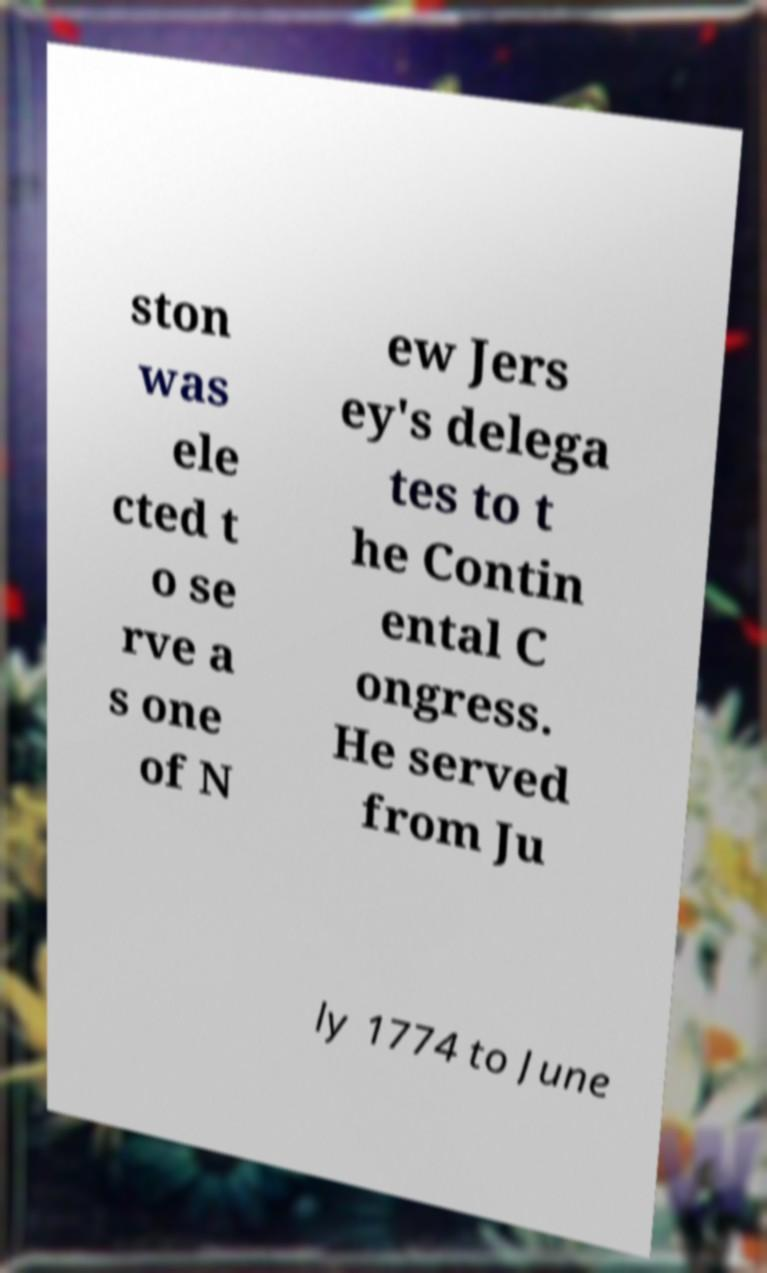Please identify and transcribe the text found in this image. ston was ele cted t o se rve a s one of N ew Jers ey's delega tes to t he Contin ental C ongress. He served from Ju ly 1774 to June 